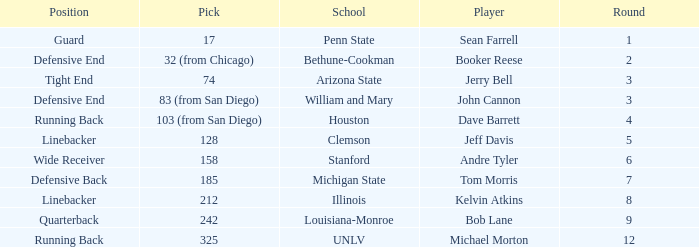Which pick was chosen by clemson? 128.0. 